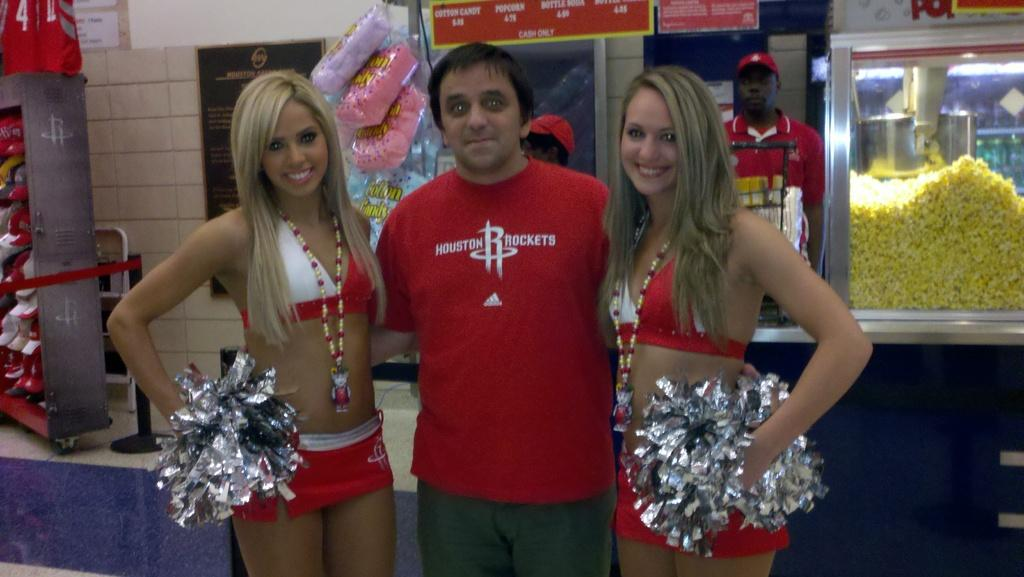<image>
Render a clear and concise summary of the photo. A man wearing a Houston Rockets t-shirt stands in between two cheerleaders 